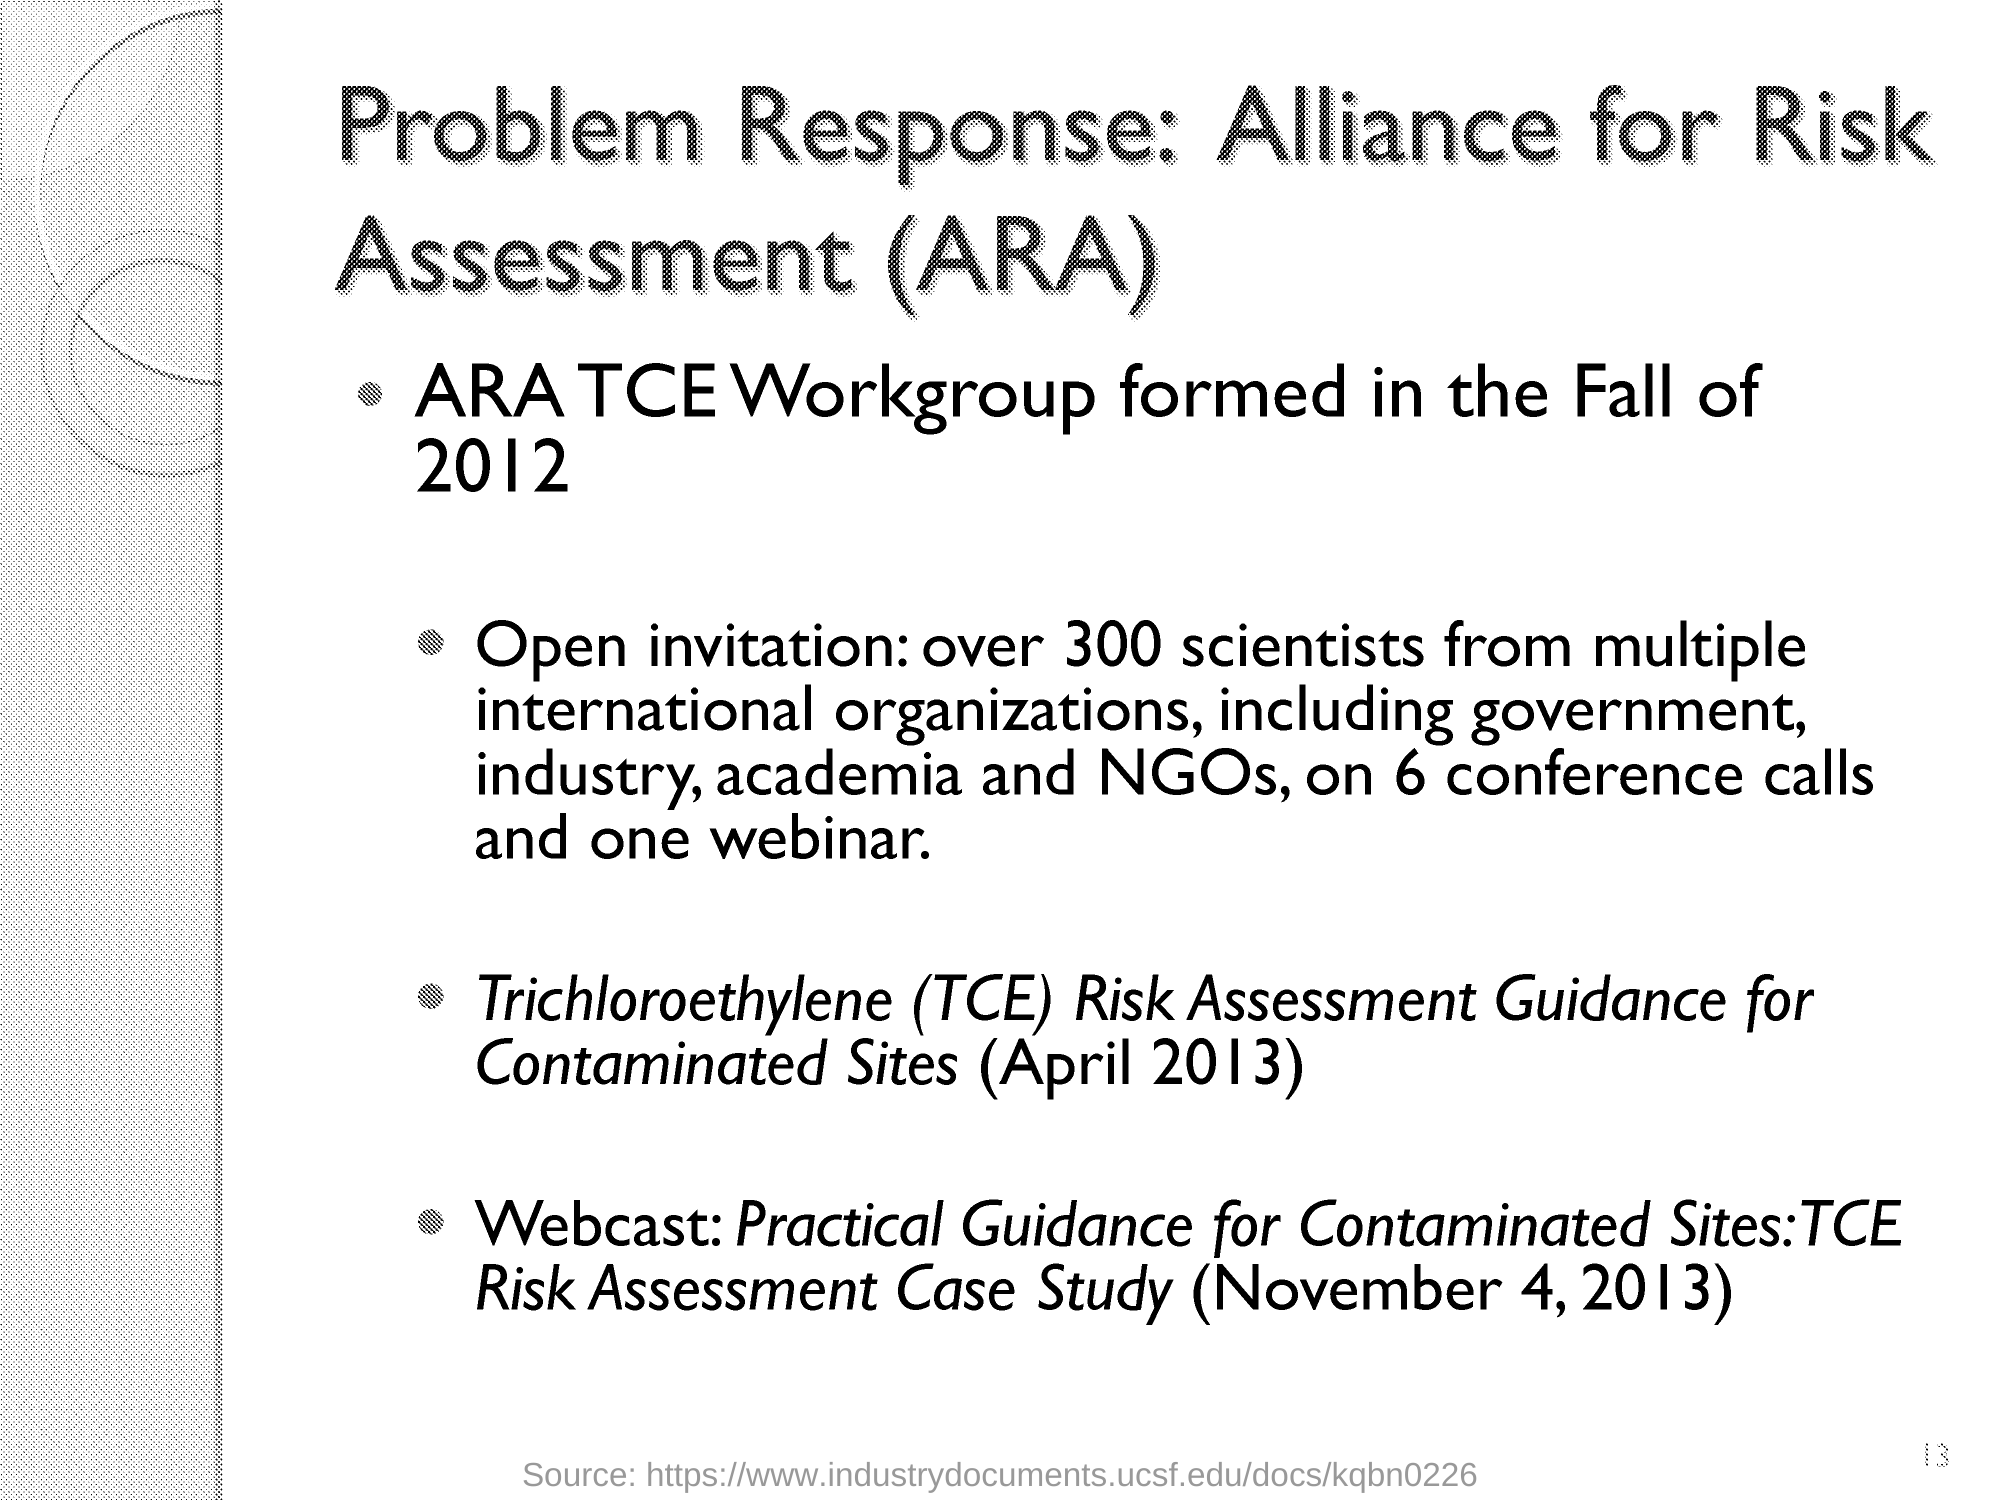What is the fullform of TCE?
Provide a short and direct response. Trichloroethylene. How many scientists from multiple international organizations are invited?
Provide a succinct answer. Over 300 scientists. When was ARA TCE Workgroup formed?
Your answer should be compact. In the fall of 2012. What is the abbreviation of Alliance for Risk Assessment?
Your answer should be very brief. ARA. 